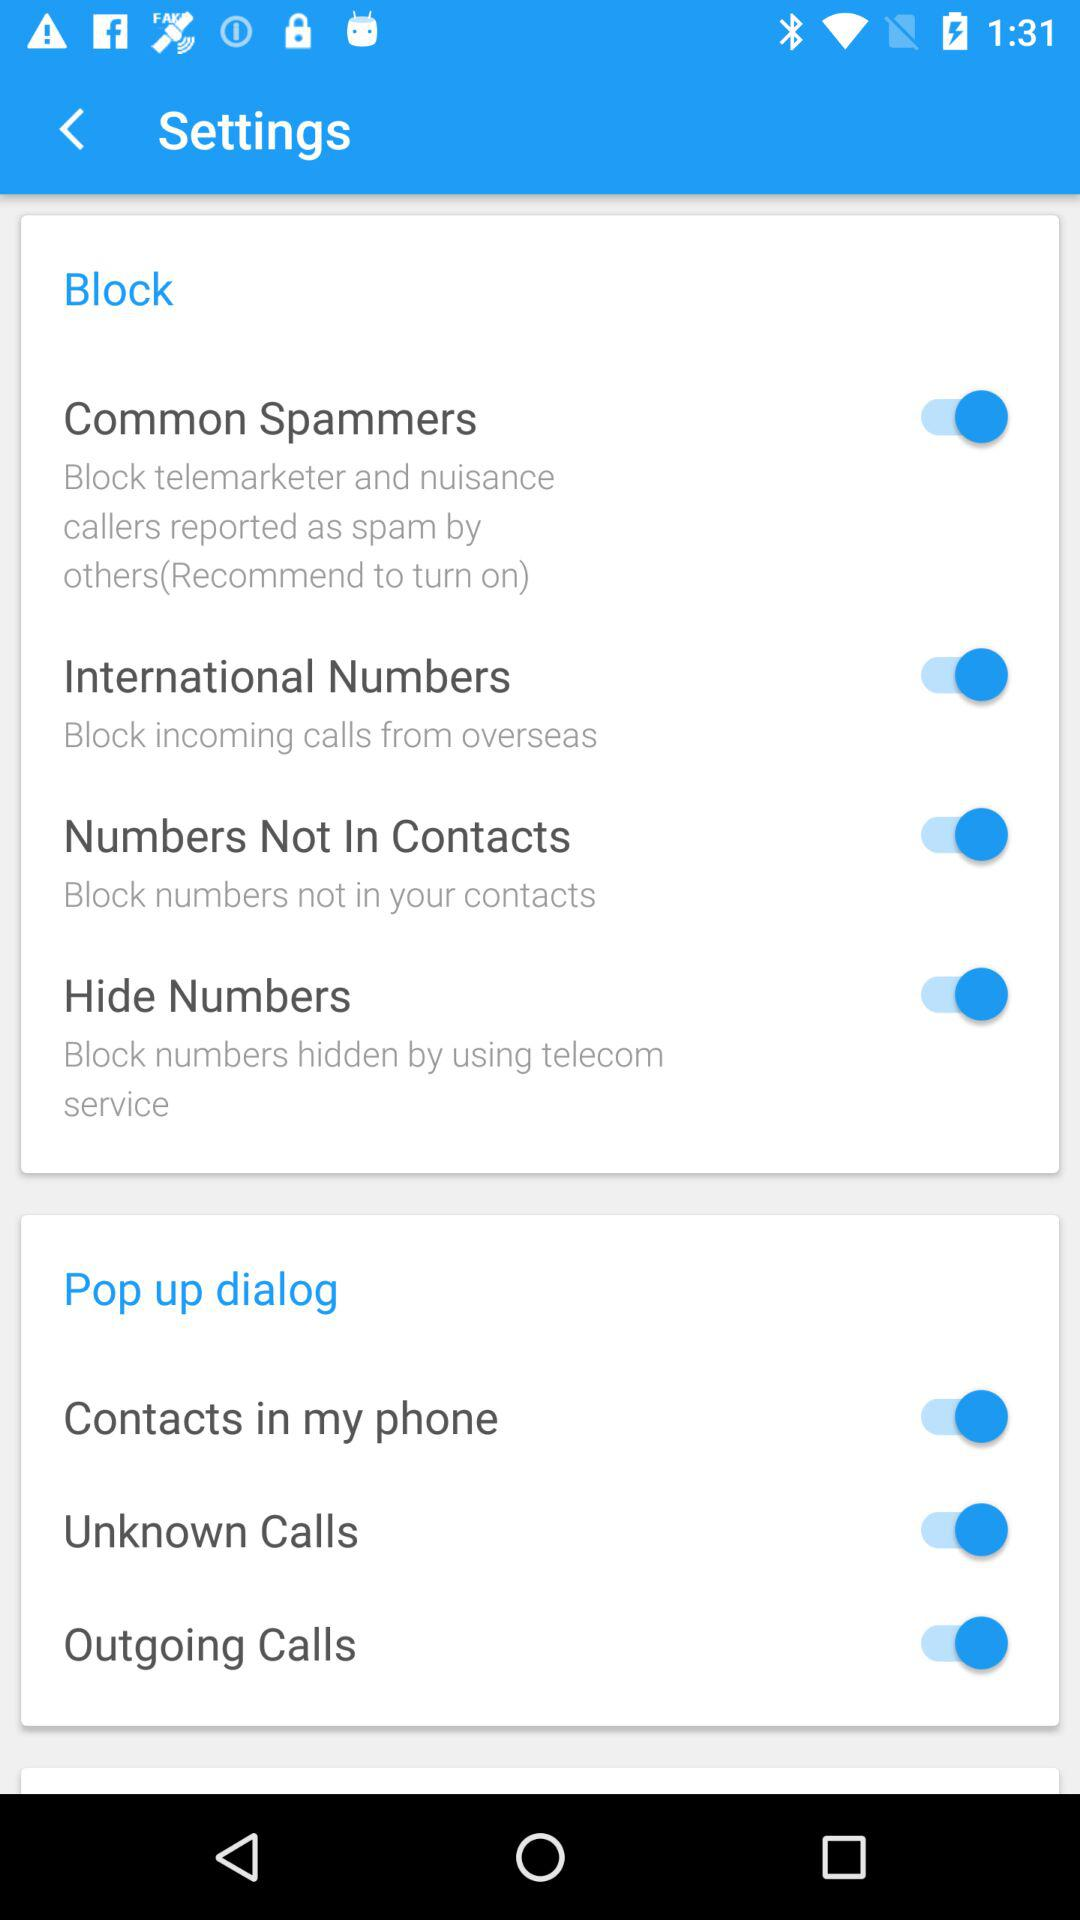How are the block numbers hidden? The block numbers are hidden by using a telecom service. 